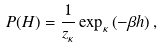<formula> <loc_0><loc_0><loc_500><loc_500>P ( H ) = \frac { 1 } { z _ { \kappa } } \exp _ { \kappa } \left ( - \beta h \right ) ,</formula> 